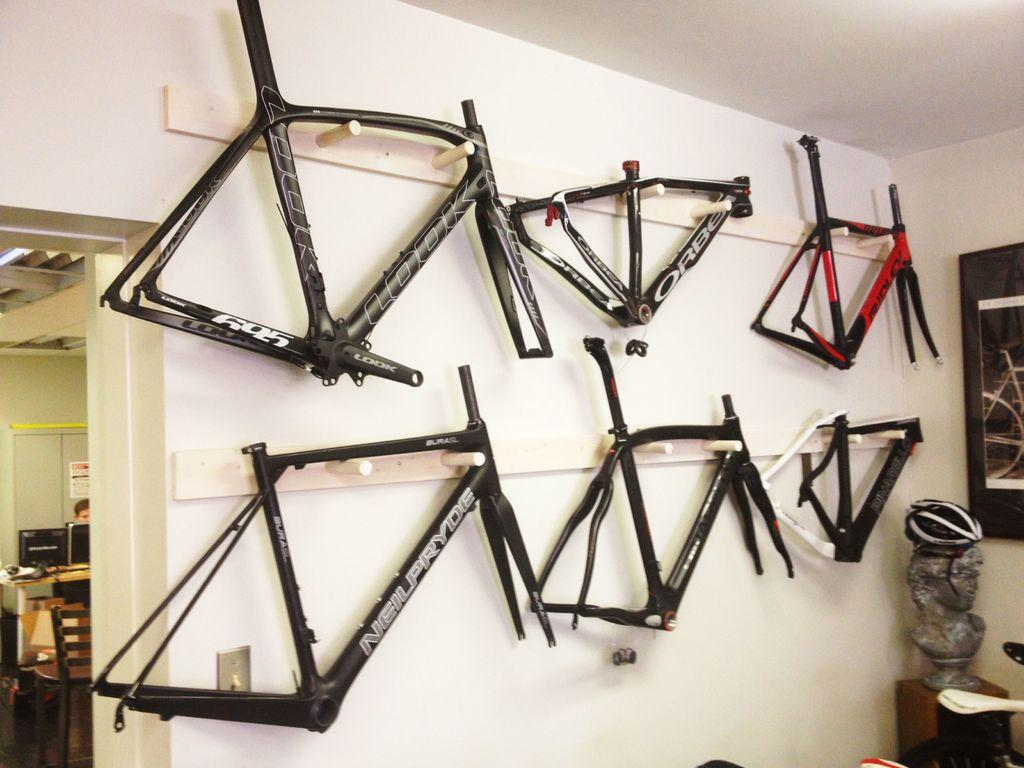What can be seen on the wall in the image? There are black objects on the wall in the image. What type of artwork or decoration is present on the wall? The black objects on the wall could be a painting, photograph, or other type of artwork or decoration. What is located in the background of the image? In the background of the image, there is a chair, a table, a person, and a monitor. Can you describe the sculpture in the image? The sculpture in the image is not described in the provided facts, so we cannot provide a detailed description. Where is the tray located in the image? There is no tray present in the image. What type of basin is visible in the image? There is no basin present in the image. 